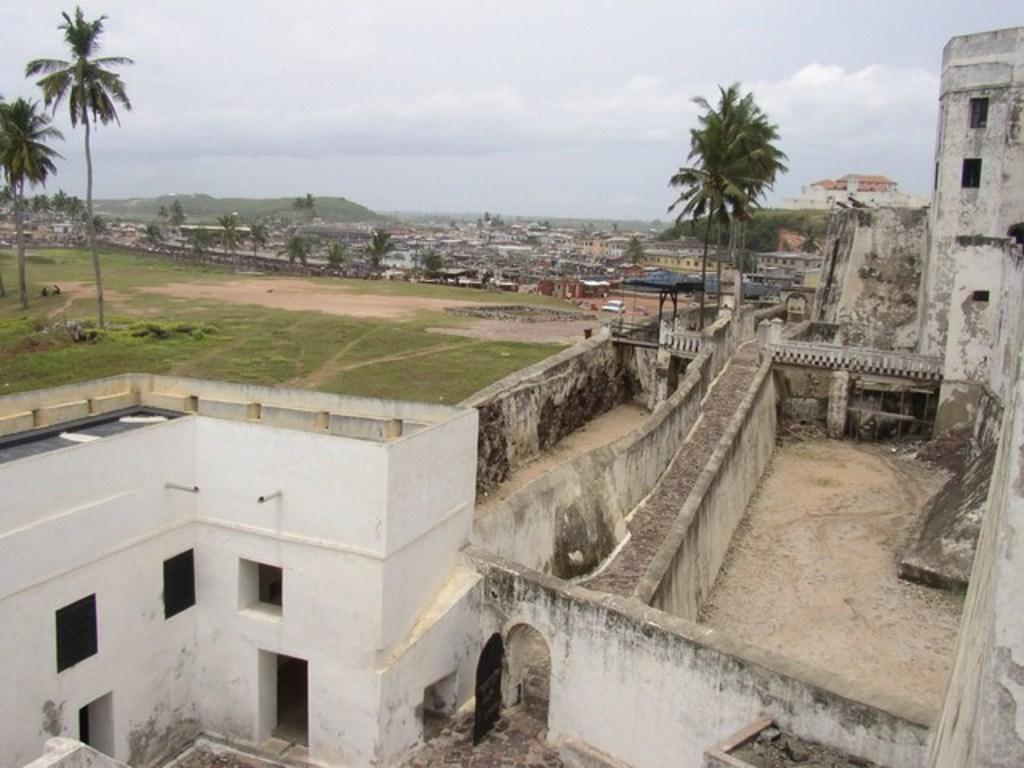What type of structure is in the image? There is a building in the image. What is located in front of the building? Trees are visible in front of the building. What can be seen in the background of the image? There are many houses and trees in the background of the image. What is visible in the sky in the image? Clouds are visible in the sky. What part of the sky is visible in the image? The sky is visible in the image. What type of oil is being used in the image? There is no reference to oil in the image. 